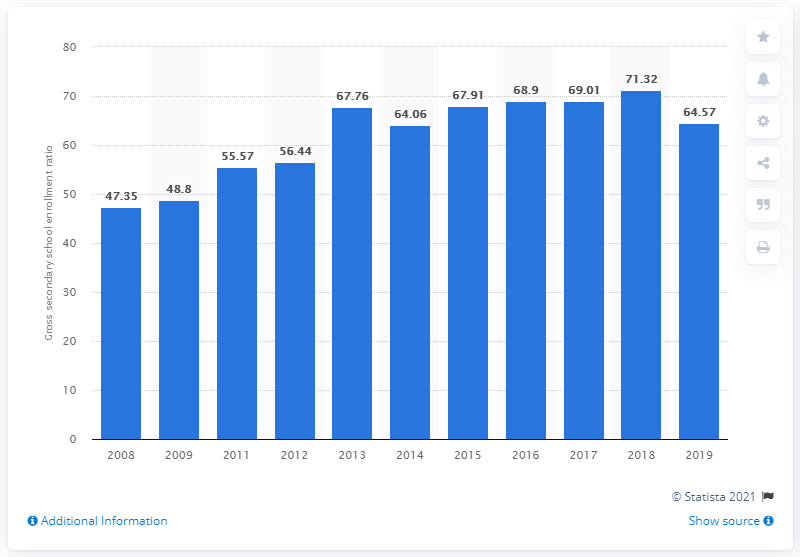Draw attention to some important aspects in this diagram. In 2018, the gross enrollment ratio for secondary school students in Ghana was 71.32%. In 2008, the enrollment ratio for secondary school students in Ghana was 47.35%. In 2019, the gross enrollment ratio for secondary school students in Ghana was 64.57. This indicates that 64.57% of eligible children between the ages of 13 and 17 were enrolled in secondary school. 